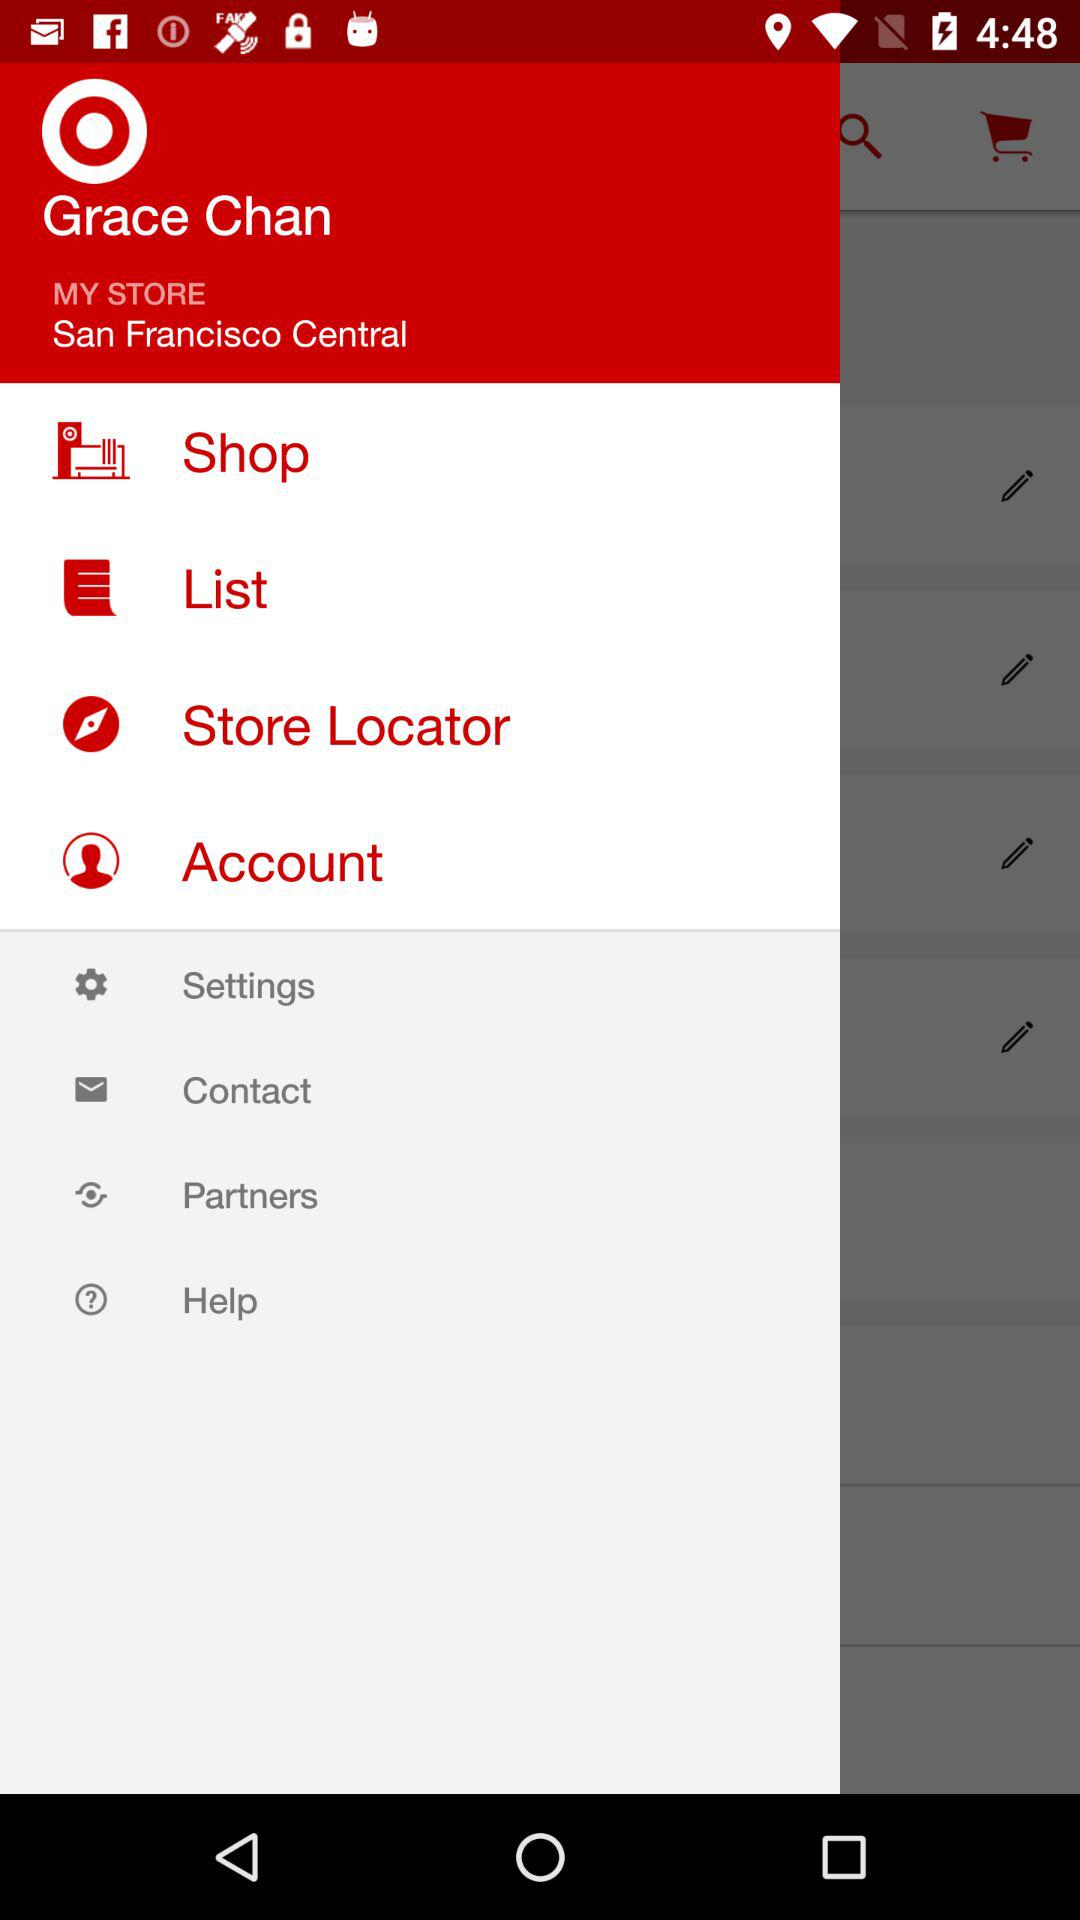What is the location? The location is San Francisco Central. 